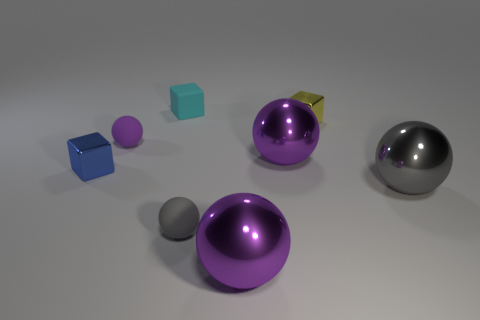What number of other objects are the same shape as the gray matte object?
Make the answer very short. 4. Do the blue object and the yellow object have the same shape?
Your answer should be very brief. Yes. What is the material of the small cyan thing that is the same shape as the small yellow metallic object?
Provide a succinct answer. Rubber. Are there any small blue metal things of the same shape as the small yellow shiny object?
Your response must be concise. Yes. Does the tiny yellow thing have the same material as the tiny thing on the left side of the purple rubber ball?
Make the answer very short. Yes. There is a cyan matte object; are there any tiny matte things in front of it?
Ensure brevity in your answer.  Yes. What number of objects are either cyan matte cylinders or balls that are on the left side of the tiny gray thing?
Make the answer very short. 1. What color is the cube that is in front of the shiny cube on the right side of the small gray sphere?
Make the answer very short. Blue. What number of other objects are there of the same material as the tiny cyan cube?
Provide a succinct answer. 2. What number of rubber things are either tiny gray spheres or tiny things?
Keep it short and to the point. 3. 